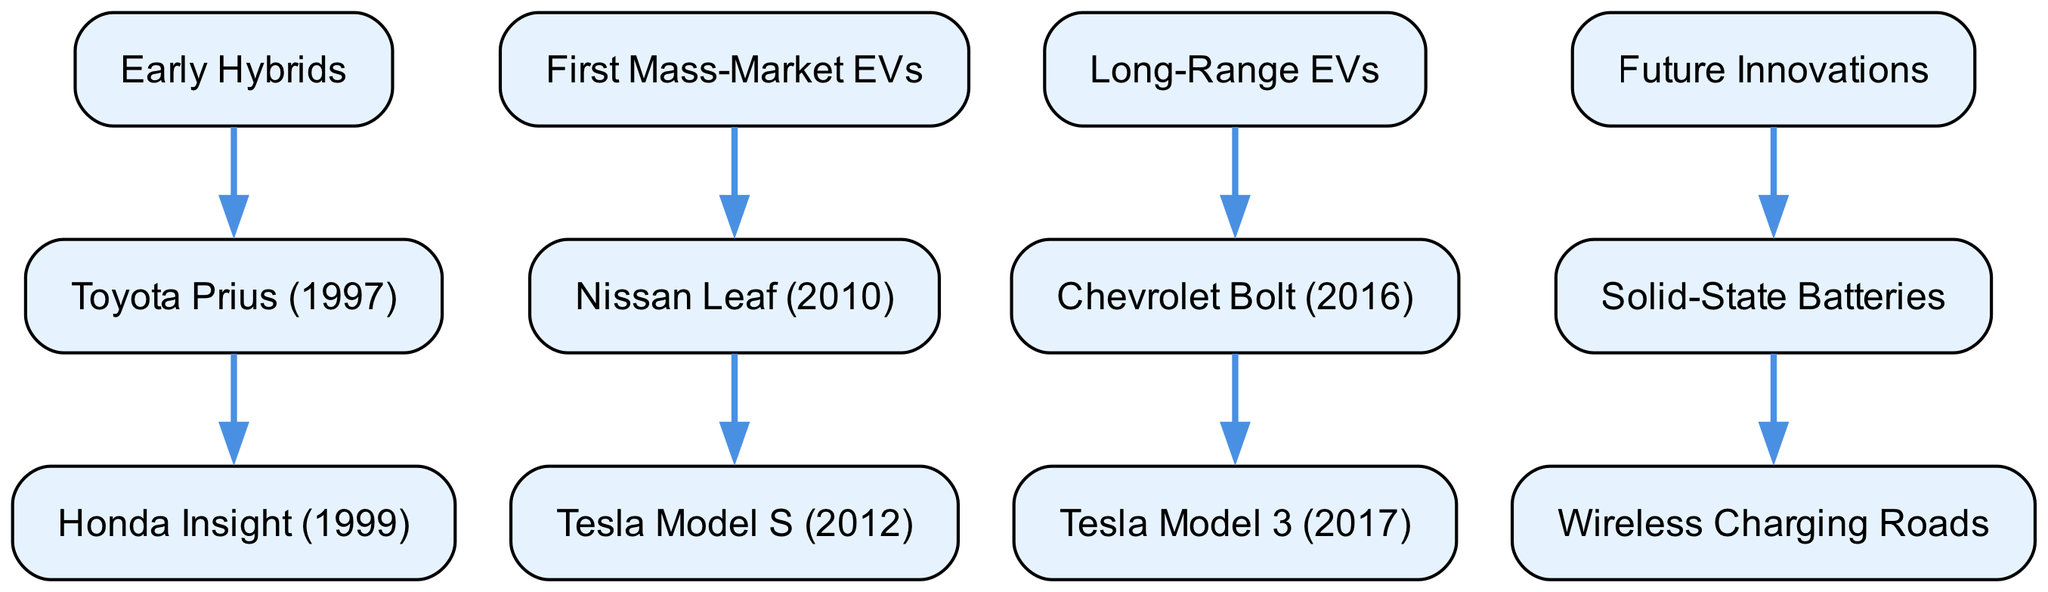What is the first model in the "Early Hybrids" category? The diagram shows "Toyota Prius (1997)" as the first listed model under the "Early Hybrids" category.
Answer: Toyota Prius (1997) How many children does "First Mass-Market EVs" have? The "First Mass-Market EVs" category has one direct child, which is the "Nissan Leaf (2010)".
Answer: 1 Which model is a child of "Long-Range EVs"? The diagram indicates that "Tesla Model 3 (2017)" is a child of the "Long-Range EVs" category under "Chevrolet Bolt (2016)".
Answer: Tesla Model 3 (2017) What is the last innovation listed in the "Future Innovations" category? According to the diagram, the last innovation listed under "Future Innovations" is "Wireless Charging Roads", which is a child of "Solid-State Batteries".
Answer: Wireless Charging Roads Which category comes immediately after "First Mass-Market EVs"? The categories are sequenced, so "Long-Range EVs" comes right after "First Mass-Market EVs" in the diagram.
Answer: Long-Range EVs How many total models are listed in the "Electric Vehicle Evolution"? By counting, we have: "Toyota Prius (1997)", "Honda Insight (1999)", "Nissan Leaf (2010)", "Tesla Model S (2012)", "Chevrolet Bolt (2016)", "Tesla Model 3 (2017)", "Solid-State Batteries", and "Wireless Charging Roads", which sums up to 8 models.
Answer: 8 What is the relationship between "Chevrolet Bolt (2016)" and "Tesla Model 3 (2017)"? The diagram shows that "Chevrolet Bolt (2016)" is the parent node of "Tesla Model 3 (2017)", meaning that the Tesla model is a child of the Chevrolet model in the hierarchy.
Answer: Parent-Child How many distinct categories are present in the diagram? There are four main categories shown: "Early Hybrids," "First Mass-Market EVs," "Long-Range EVs," and "Future Innovations".
Answer: 4 Which model was released in 1999? The diagram specifies "Honda Insight (1999)" as the model that was released in 1999 under the "Early Hybrids" category.
Answer: Honda Insight (1999) 